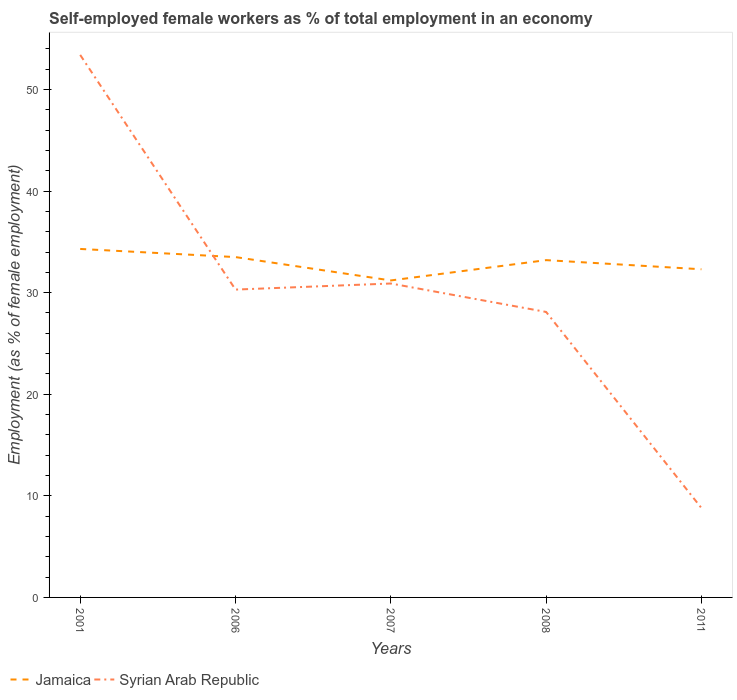Does the line corresponding to Syrian Arab Republic intersect with the line corresponding to Jamaica?
Make the answer very short. Yes. Is the number of lines equal to the number of legend labels?
Provide a short and direct response. Yes. Across all years, what is the maximum percentage of self-employed female workers in Jamaica?
Provide a succinct answer. 31.2. What is the total percentage of self-employed female workers in Syrian Arab Republic in the graph?
Keep it short and to the point. 21.5. What is the difference between the highest and the second highest percentage of self-employed female workers in Jamaica?
Ensure brevity in your answer.  3.1. What is the difference between the highest and the lowest percentage of self-employed female workers in Syrian Arab Republic?
Give a very brief answer. 2. Is the percentage of self-employed female workers in Jamaica strictly greater than the percentage of self-employed female workers in Syrian Arab Republic over the years?
Your answer should be compact. No. How many lines are there?
Keep it short and to the point. 2. How many years are there in the graph?
Offer a terse response. 5. What is the difference between two consecutive major ticks on the Y-axis?
Provide a succinct answer. 10. How many legend labels are there?
Provide a succinct answer. 2. What is the title of the graph?
Provide a succinct answer. Self-employed female workers as % of total employment in an economy. What is the label or title of the X-axis?
Provide a short and direct response. Years. What is the label or title of the Y-axis?
Ensure brevity in your answer.  Employment (as % of female employment). What is the Employment (as % of female employment) in Jamaica in 2001?
Provide a short and direct response. 34.3. What is the Employment (as % of female employment) in Syrian Arab Republic in 2001?
Provide a succinct answer. 53.4. What is the Employment (as % of female employment) of Jamaica in 2006?
Your response must be concise. 33.5. What is the Employment (as % of female employment) in Syrian Arab Republic in 2006?
Keep it short and to the point. 30.3. What is the Employment (as % of female employment) in Jamaica in 2007?
Keep it short and to the point. 31.2. What is the Employment (as % of female employment) in Syrian Arab Republic in 2007?
Offer a terse response. 30.9. What is the Employment (as % of female employment) in Jamaica in 2008?
Ensure brevity in your answer.  33.2. What is the Employment (as % of female employment) of Syrian Arab Republic in 2008?
Ensure brevity in your answer.  28.1. What is the Employment (as % of female employment) of Jamaica in 2011?
Offer a very short reply. 32.3. What is the Employment (as % of female employment) of Syrian Arab Republic in 2011?
Keep it short and to the point. 8.8. Across all years, what is the maximum Employment (as % of female employment) in Jamaica?
Keep it short and to the point. 34.3. Across all years, what is the maximum Employment (as % of female employment) of Syrian Arab Republic?
Provide a succinct answer. 53.4. Across all years, what is the minimum Employment (as % of female employment) of Jamaica?
Give a very brief answer. 31.2. Across all years, what is the minimum Employment (as % of female employment) in Syrian Arab Republic?
Provide a succinct answer. 8.8. What is the total Employment (as % of female employment) in Jamaica in the graph?
Your response must be concise. 164.5. What is the total Employment (as % of female employment) of Syrian Arab Republic in the graph?
Make the answer very short. 151.5. What is the difference between the Employment (as % of female employment) of Syrian Arab Republic in 2001 and that in 2006?
Keep it short and to the point. 23.1. What is the difference between the Employment (as % of female employment) of Jamaica in 2001 and that in 2008?
Your answer should be compact. 1.1. What is the difference between the Employment (as % of female employment) in Syrian Arab Republic in 2001 and that in 2008?
Offer a terse response. 25.3. What is the difference between the Employment (as % of female employment) in Jamaica in 2001 and that in 2011?
Provide a short and direct response. 2. What is the difference between the Employment (as % of female employment) in Syrian Arab Republic in 2001 and that in 2011?
Your answer should be compact. 44.6. What is the difference between the Employment (as % of female employment) in Jamaica in 2006 and that in 2007?
Your response must be concise. 2.3. What is the difference between the Employment (as % of female employment) in Syrian Arab Republic in 2007 and that in 2011?
Your answer should be compact. 22.1. What is the difference between the Employment (as % of female employment) of Syrian Arab Republic in 2008 and that in 2011?
Ensure brevity in your answer.  19.3. What is the difference between the Employment (as % of female employment) of Jamaica in 2001 and the Employment (as % of female employment) of Syrian Arab Republic in 2007?
Your answer should be compact. 3.4. What is the difference between the Employment (as % of female employment) in Jamaica in 2001 and the Employment (as % of female employment) in Syrian Arab Republic in 2008?
Your answer should be very brief. 6.2. What is the difference between the Employment (as % of female employment) of Jamaica in 2006 and the Employment (as % of female employment) of Syrian Arab Republic in 2007?
Ensure brevity in your answer.  2.6. What is the difference between the Employment (as % of female employment) of Jamaica in 2006 and the Employment (as % of female employment) of Syrian Arab Republic in 2008?
Provide a succinct answer. 5.4. What is the difference between the Employment (as % of female employment) of Jamaica in 2006 and the Employment (as % of female employment) of Syrian Arab Republic in 2011?
Ensure brevity in your answer.  24.7. What is the difference between the Employment (as % of female employment) of Jamaica in 2007 and the Employment (as % of female employment) of Syrian Arab Republic in 2008?
Keep it short and to the point. 3.1. What is the difference between the Employment (as % of female employment) in Jamaica in 2007 and the Employment (as % of female employment) in Syrian Arab Republic in 2011?
Make the answer very short. 22.4. What is the difference between the Employment (as % of female employment) in Jamaica in 2008 and the Employment (as % of female employment) in Syrian Arab Republic in 2011?
Give a very brief answer. 24.4. What is the average Employment (as % of female employment) of Jamaica per year?
Your answer should be compact. 32.9. What is the average Employment (as % of female employment) of Syrian Arab Republic per year?
Provide a succinct answer. 30.3. In the year 2001, what is the difference between the Employment (as % of female employment) of Jamaica and Employment (as % of female employment) of Syrian Arab Republic?
Offer a very short reply. -19.1. In the year 2006, what is the difference between the Employment (as % of female employment) of Jamaica and Employment (as % of female employment) of Syrian Arab Republic?
Provide a succinct answer. 3.2. In the year 2011, what is the difference between the Employment (as % of female employment) of Jamaica and Employment (as % of female employment) of Syrian Arab Republic?
Keep it short and to the point. 23.5. What is the ratio of the Employment (as % of female employment) in Jamaica in 2001 to that in 2006?
Provide a short and direct response. 1.02. What is the ratio of the Employment (as % of female employment) in Syrian Arab Republic in 2001 to that in 2006?
Provide a succinct answer. 1.76. What is the ratio of the Employment (as % of female employment) in Jamaica in 2001 to that in 2007?
Your response must be concise. 1.1. What is the ratio of the Employment (as % of female employment) in Syrian Arab Republic in 2001 to that in 2007?
Give a very brief answer. 1.73. What is the ratio of the Employment (as % of female employment) of Jamaica in 2001 to that in 2008?
Offer a terse response. 1.03. What is the ratio of the Employment (as % of female employment) in Syrian Arab Republic in 2001 to that in 2008?
Ensure brevity in your answer.  1.9. What is the ratio of the Employment (as % of female employment) in Jamaica in 2001 to that in 2011?
Make the answer very short. 1.06. What is the ratio of the Employment (as % of female employment) of Syrian Arab Republic in 2001 to that in 2011?
Your answer should be compact. 6.07. What is the ratio of the Employment (as % of female employment) of Jamaica in 2006 to that in 2007?
Provide a succinct answer. 1.07. What is the ratio of the Employment (as % of female employment) of Syrian Arab Republic in 2006 to that in 2007?
Your response must be concise. 0.98. What is the ratio of the Employment (as % of female employment) of Jamaica in 2006 to that in 2008?
Your answer should be very brief. 1.01. What is the ratio of the Employment (as % of female employment) in Syrian Arab Republic in 2006 to that in 2008?
Provide a short and direct response. 1.08. What is the ratio of the Employment (as % of female employment) in Jamaica in 2006 to that in 2011?
Keep it short and to the point. 1.04. What is the ratio of the Employment (as % of female employment) in Syrian Arab Republic in 2006 to that in 2011?
Make the answer very short. 3.44. What is the ratio of the Employment (as % of female employment) in Jamaica in 2007 to that in 2008?
Provide a short and direct response. 0.94. What is the ratio of the Employment (as % of female employment) in Syrian Arab Republic in 2007 to that in 2008?
Offer a very short reply. 1.1. What is the ratio of the Employment (as % of female employment) in Jamaica in 2007 to that in 2011?
Offer a very short reply. 0.97. What is the ratio of the Employment (as % of female employment) in Syrian Arab Republic in 2007 to that in 2011?
Make the answer very short. 3.51. What is the ratio of the Employment (as % of female employment) of Jamaica in 2008 to that in 2011?
Your answer should be compact. 1.03. What is the ratio of the Employment (as % of female employment) of Syrian Arab Republic in 2008 to that in 2011?
Make the answer very short. 3.19. What is the difference between the highest and the second highest Employment (as % of female employment) in Jamaica?
Offer a very short reply. 0.8. What is the difference between the highest and the second highest Employment (as % of female employment) of Syrian Arab Republic?
Offer a terse response. 22.5. What is the difference between the highest and the lowest Employment (as % of female employment) of Syrian Arab Republic?
Offer a terse response. 44.6. 